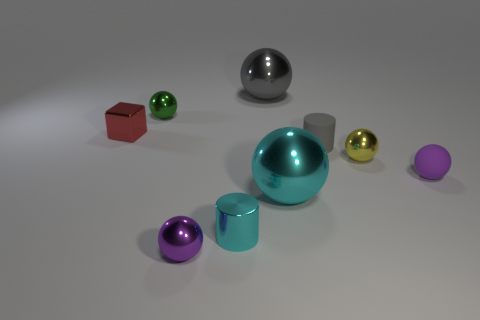Subtract all cyan spheres. How many spheres are left? 5 Subtract all gray spheres. How many spheres are left? 5 Subtract all cyan balls. Subtract all gray cylinders. How many balls are left? 5 Subtract all blocks. How many objects are left? 8 Add 4 tiny matte objects. How many tiny matte objects are left? 6 Add 2 tiny blue spheres. How many tiny blue spheres exist? 2 Subtract 0 yellow cubes. How many objects are left? 9 Subtract all purple metallic cylinders. Subtract all cyan metal balls. How many objects are left? 8 